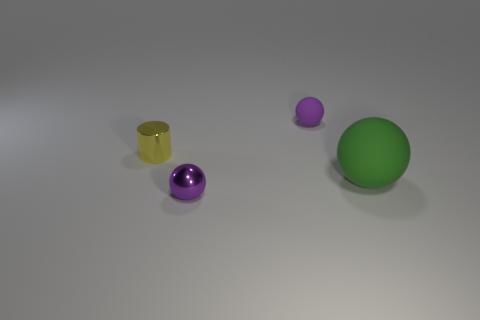Add 1 yellow cylinders. How many objects exist? 5 Subtract all spheres. How many objects are left? 1 Subtract all cylinders. Subtract all yellow objects. How many objects are left? 2 Add 2 small purple balls. How many small purple balls are left? 4 Add 1 small purple rubber spheres. How many small purple rubber spheres exist? 2 Subtract 0 brown balls. How many objects are left? 4 